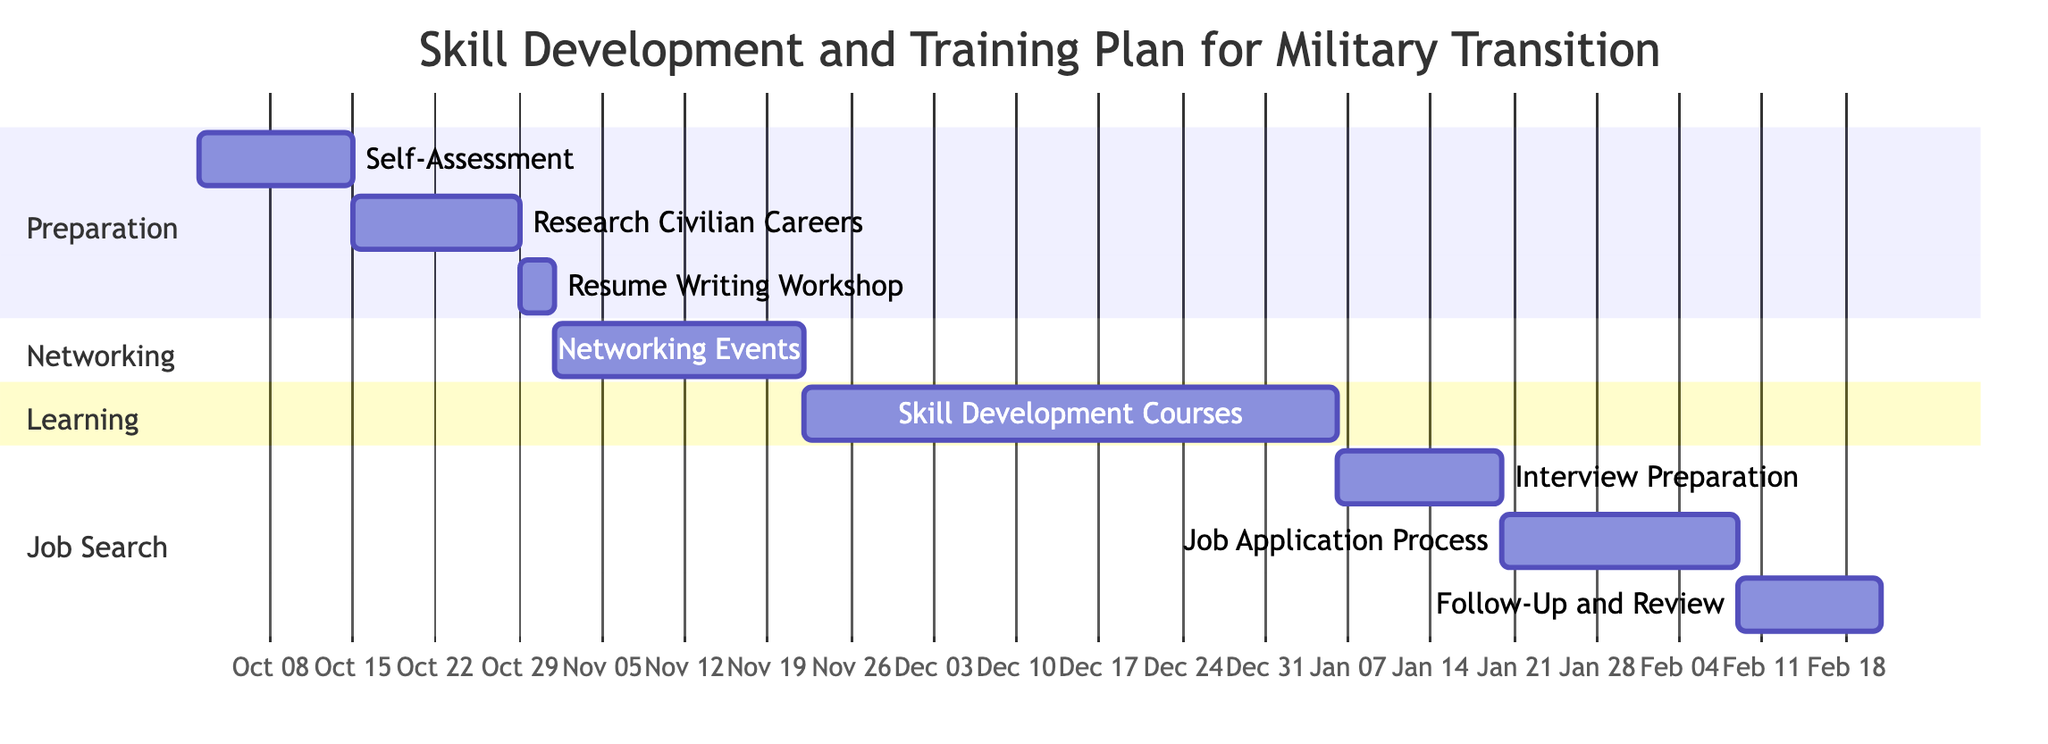What is the duration of the "Self-Assessment" task? The "Self-Assessment" task starts on October 2, 2023, and ends on October 15, 2023. To calculate the duration, count the number of days between these two dates, which totals 13 days.
Answer: 13 days How many weeks does the "Networking Events" task last? The "Networking Events" task begins on November 4, 2023, and concludes on November 25, 2023. The duration is 21 days, which can be converted into weeks by dividing by 7, resulting in 3 weeks.
Answer: 3 weeks Which task follows "Resume Writing Workshop"? According to the Gantt chart sequence, after "Resume Writing Workshop", the next task is "Networking Events". This can be determined by the order of tasks listed in the diagram.
Answer: Networking Events When does the "Skill Development Courses" task start? The "Skill Development Courses" task begins after the "Networking Events," which ends on January 10, 2024. It starts on January 26, 2024, based on the information provided.
Answer: January 26, 2024 How many total tasks are there in the Gantt chart? The Gantt chart lists a total of eight tasks, which can be counted by reviewing the task names provided in each section of the diagram.
Answer: 8 tasks What is the end date for the "Follow-Up and Review" task? The “Follow-Up and Review” task starts on February 16, 2024, and lasts for 12 days, concluding on February 28, 2024. This date can be found directly from the chart details.
Answer: February 28, 2024 Which section contains the "Interview Preparation" task? The "Interview Preparation" task is located in the “Job Search” section of the Gantt chart. This relates to how tasks are grouped under different sections as per the diagram.
Answer: Job Search What is the total duration of the "Skill Development Courses" task in days? The "Skill Development Courses" start on November 26, 2023, and end on January 10, 2024. Counting the days between these two dates gives a total of 45 days duration.
Answer: 45 days 